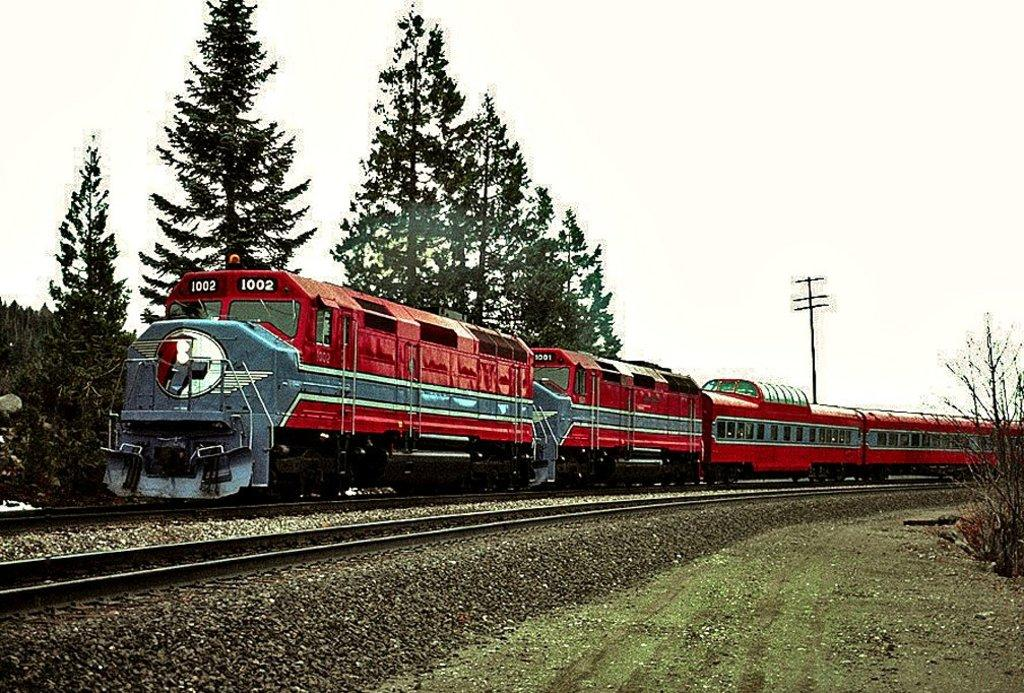What can be seen in the foreground of the picture? In the foreground of the picture, there are stones, a railway track, grass, and plants. What is located in the center of the picture? In the center of the picture, there are trees, a train, a track, and a current pole. How would you describe the sky in the picture? The sky in the picture is cloudy. How many mice are sitting on the tongue of the train in the image? There are no mice or tongues present in the image. What type of rock is being used as a paperweight on the train? There is no rock or paperweight visible in the image. 